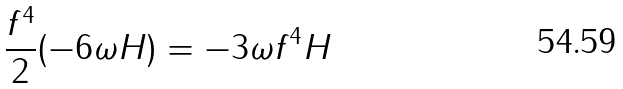<formula> <loc_0><loc_0><loc_500><loc_500>\frac { f ^ { 4 } } { 2 } ( - 6 \omega H ) = - 3 \omega f ^ { 4 } H</formula> 